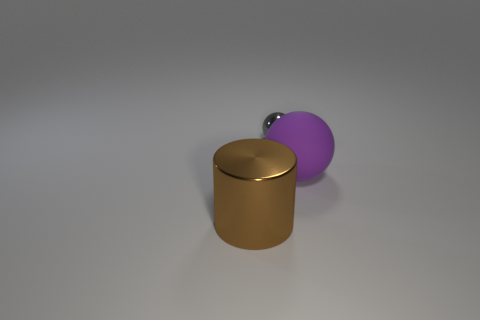What materials are the objects in the image likely made of? The object on the left with a brownish color and reflective surface suggests it could be made of metal, potentially brass or bronze given its hue. The sphere, having a matte finish and what appears to be a slightly softer texture, might be made of a rubber-like material. 